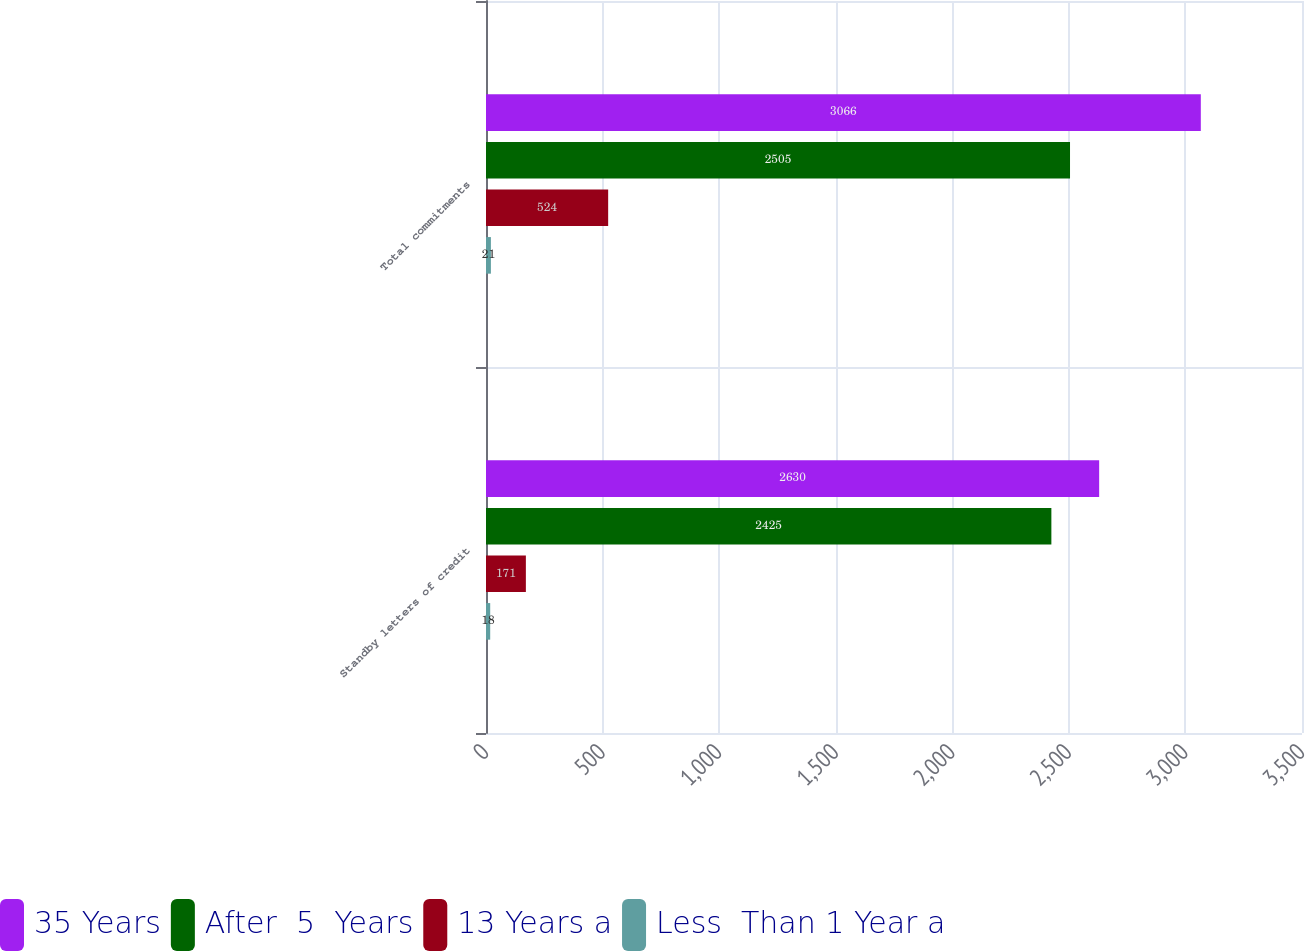Convert chart. <chart><loc_0><loc_0><loc_500><loc_500><stacked_bar_chart><ecel><fcel>Standby letters of credit<fcel>Total commitments<nl><fcel>35 Years<fcel>2630<fcel>3066<nl><fcel>After  5  Years<fcel>2425<fcel>2505<nl><fcel>13 Years a<fcel>171<fcel>524<nl><fcel>Less  Than 1 Year a<fcel>18<fcel>21<nl></chart> 